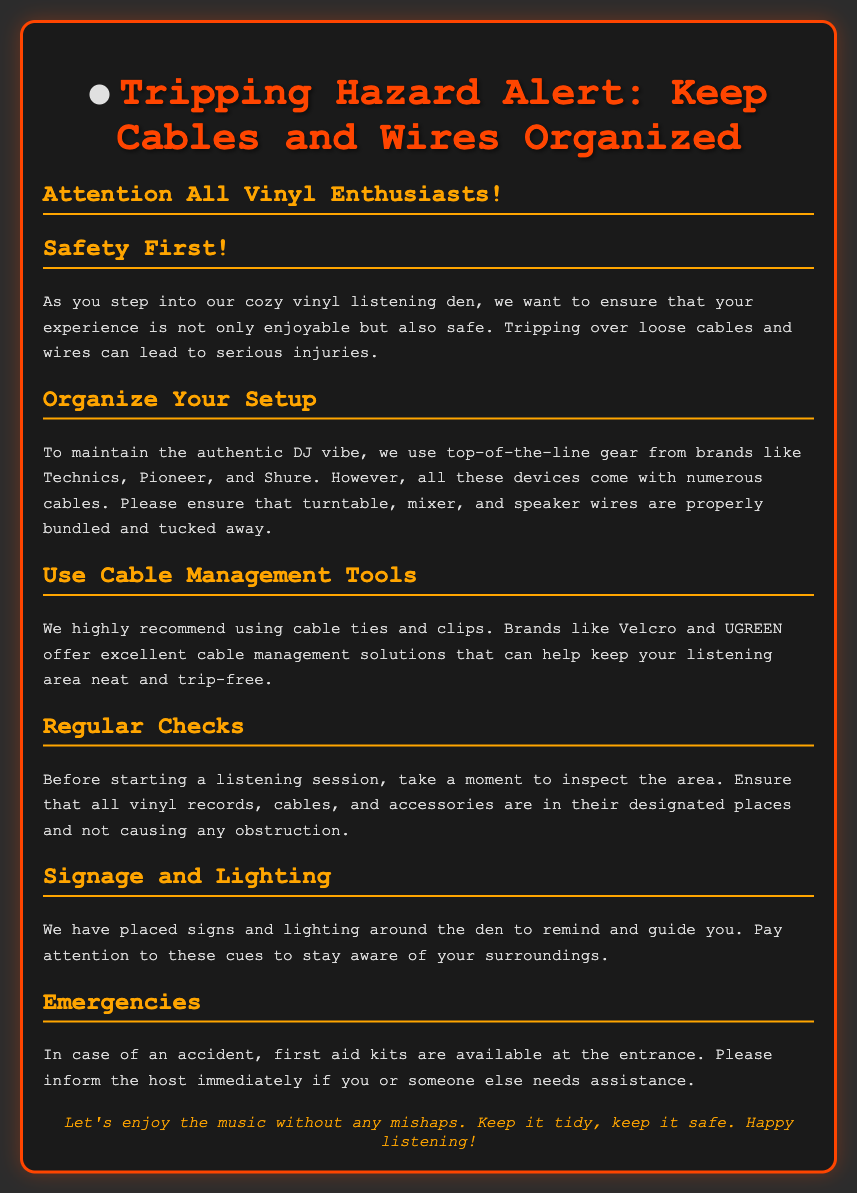What is the title of the document? The title is specified in the header of the document, indicating the focus of the warning label.
Answer: Tripping Hazard Alert: Keep Cables and Wires Organized What color is used for the border of the warning label? The border color is mentioned in the styling section, which highlights the warning aspect of the label.
Answer: #ff4500 Which brands are mentioned for the equipment? The brands are detailed in the section discussing the audio equipment in the listening den.
Answer: Technics, Pioneer, and Shure What should you use to manage cables? The document recommends specific tools for cable management to avoid tripping hazards.
Answer: Cable ties and clips What should you do before starting a listening session? The document specifies a precautionary action to ensure a safe environment before enjoying music.
Answer: Inspect the area Where are first aid kits available? The location of first aid kits is mentioned in the section on emergencies.
Answer: At the entrance Why is it important to organize cables? The document explains the safety concern associated with loose cables and wires in the listening area.
Answer: To prevent tripping hazards What is the main purpose of the document? The document provides guidelines for safety and organization in a specific environment.
Answer: Safety Alert What color is the footer text? The footer color is specified to provide visibility against the background.
Answer: #ffa500 